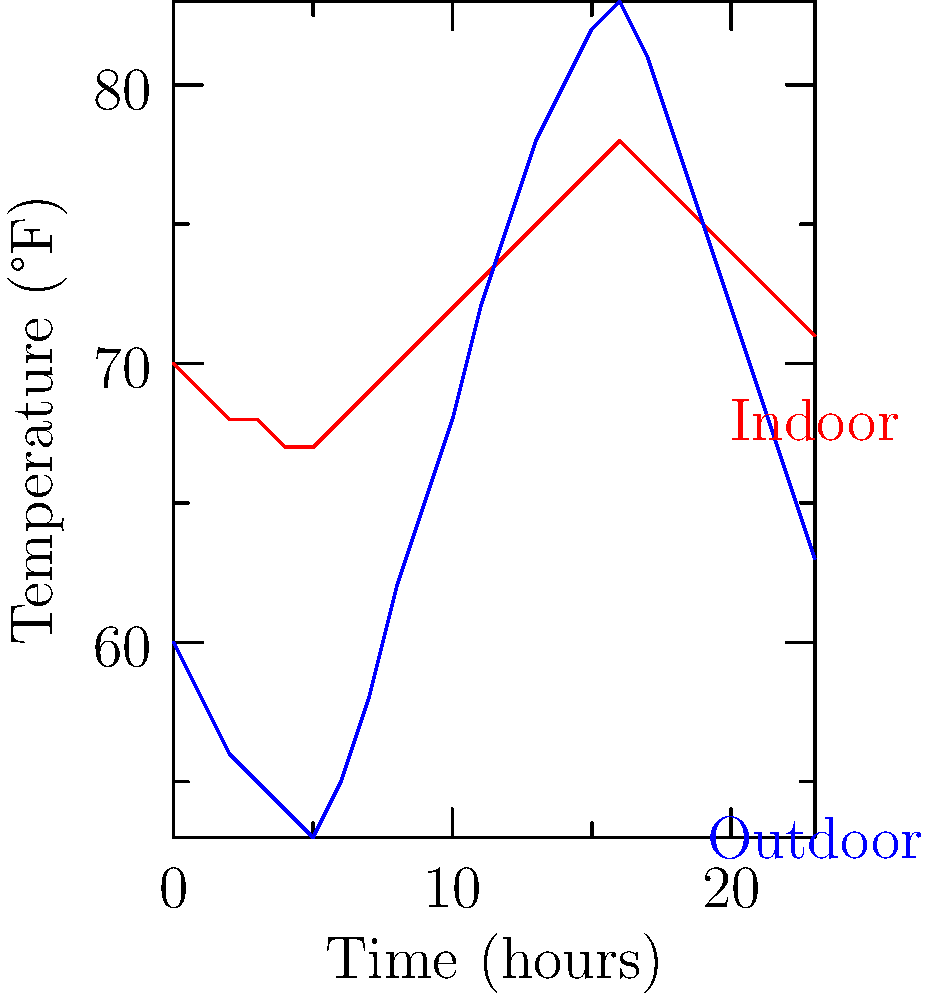Based on the temperature graph showing indoor and outdoor temperatures over 24 hours, at what time does the outdoor temperature peak and how does it compare to the indoor temperature at that time? To answer this question, we need to follow these steps:

1. Examine the blue line representing outdoor temperature.
2. Identify the highest point on the blue line.
3. Determine the time (x-axis) corresponding to this peak.
4. Compare the outdoor temperature at this peak to the indoor temperature (red line) at the same time.

Analyzing the graph:
1. The blue line represents the outdoor temperature.
2. The highest point on the blue line occurs at the 16-hour mark.
3. This corresponds to 4:00 PM (assuming the graph starts at midnight).
4. At the 16-hour mark:
   - Outdoor temperature (blue line) is at its peak of approximately 83°F
   - Indoor temperature (red line) is approximately 77°F

Therefore, the outdoor temperature peaks at 4:00 PM and is about 6°F higher than the indoor temperature at that time.
Answer: 4:00 PM; 6°F higher than indoor 